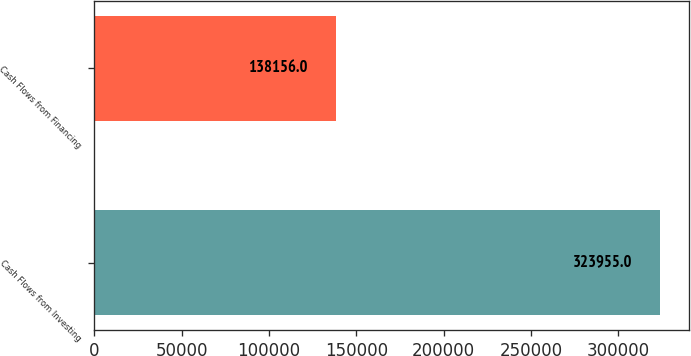<chart> <loc_0><loc_0><loc_500><loc_500><bar_chart><fcel>Cash Flows from Investing<fcel>Cash Flows from Financing<nl><fcel>323955<fcel>138156<nl></chart> 